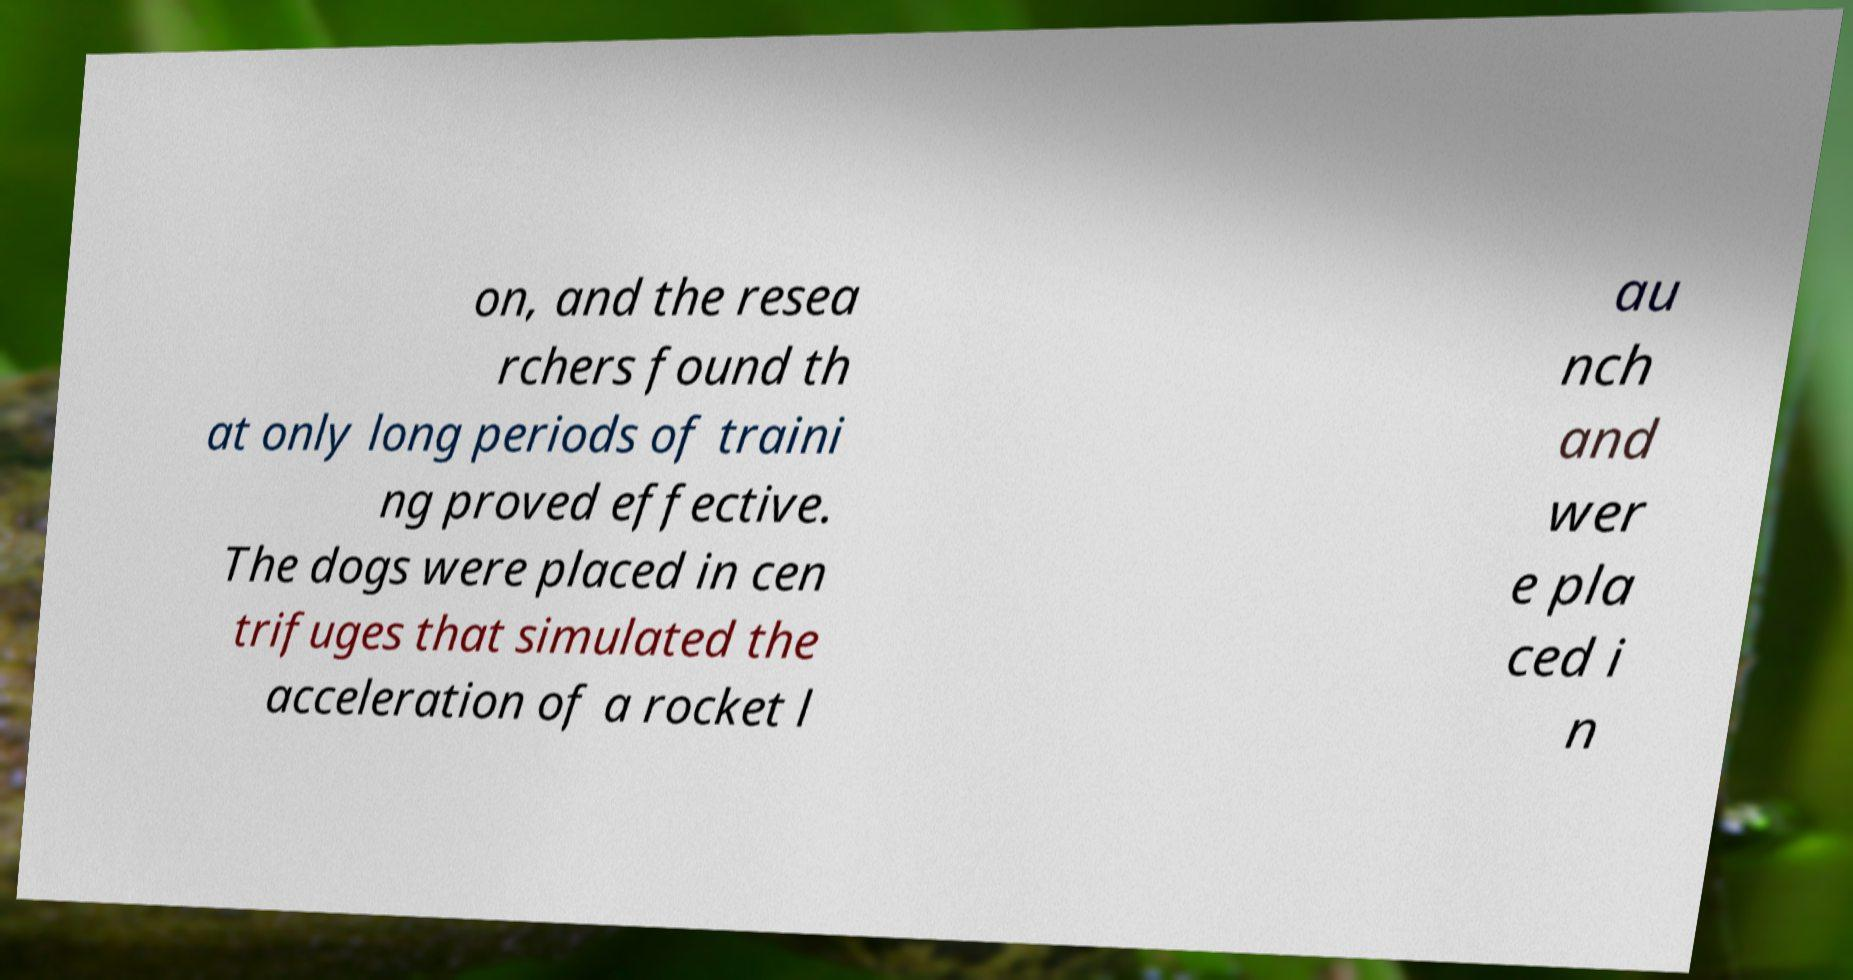Can you read and provide the text displayed in the image?This photo seems to have some interesting text. Can you extract and type it out for me? on, and the resea rchers found th at only long periods of traini ng proved effective. The dogs were placed in cen trifuges that simulated the acceleration of a rocket l au nch and wer e pla ced i n 